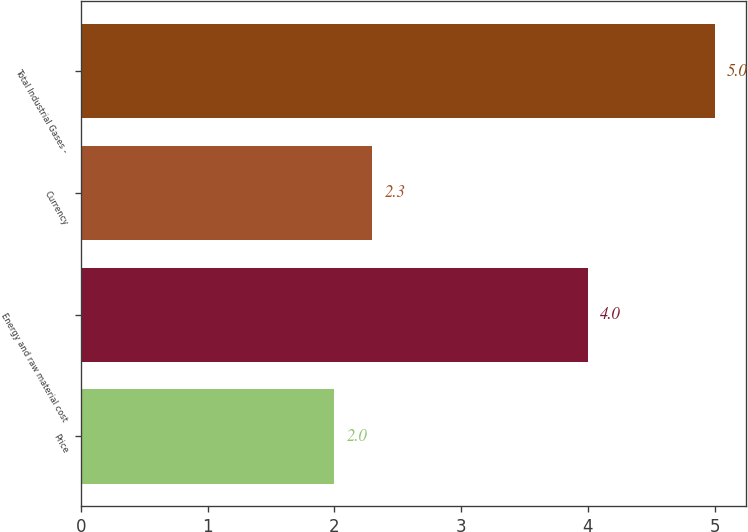Convert chart to OTSL. <chart><loc_0><loc_0><loc_500><loc_500><bar_chart><fcel>Price<fcel>Energy and raw material cost<fcel>Currency<fcel>Total Industrial Gases -<nl><fcel>2<fcel>4<fcel>2.3<fcel>5<nl></chart> 